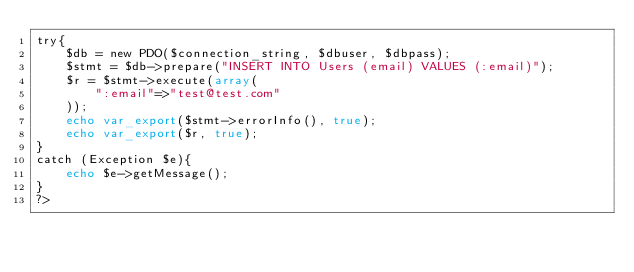<code> <loc_0><loc_0><loc_500><loc_500><_PHP_>try{
    $db = new PDO($connection_string, $dbuser, $dbpass);
    $stmt = $db->prepare("INSERT INTO Users (email) VALUES (:email)");
    $r = $stmt->execute(array(
        ":email"=>"test@test.com"
    ));
    echo var_export($stmt->errorInfo(), true);
    echo var_export($r, true);
}
catch (Exception $e){
    echo $e->getMessage();
}
?>
</code> 